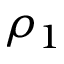Convert formula to latex. <formula><loc_0><loc_0><loc_500><loc_500>\rho _ { 1 }</formula> 